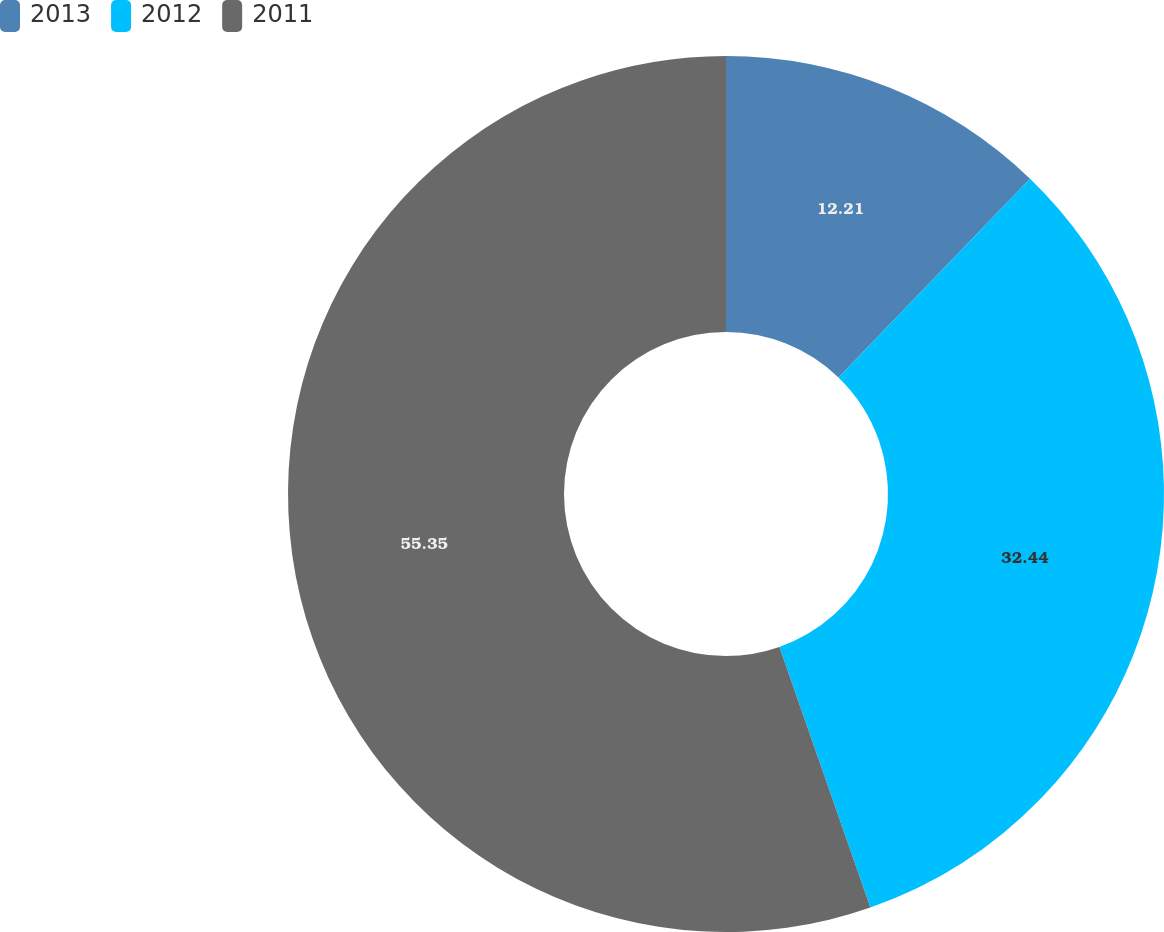Convert chart. <chart><loc_0><loc_0><loc_500><loc_500><pie_chart><fcel>2013<fcel>2012<fcel>2011<nl><fcel>12.21%<fcel>32.44%<fcel>55.34%<nl></chart> 